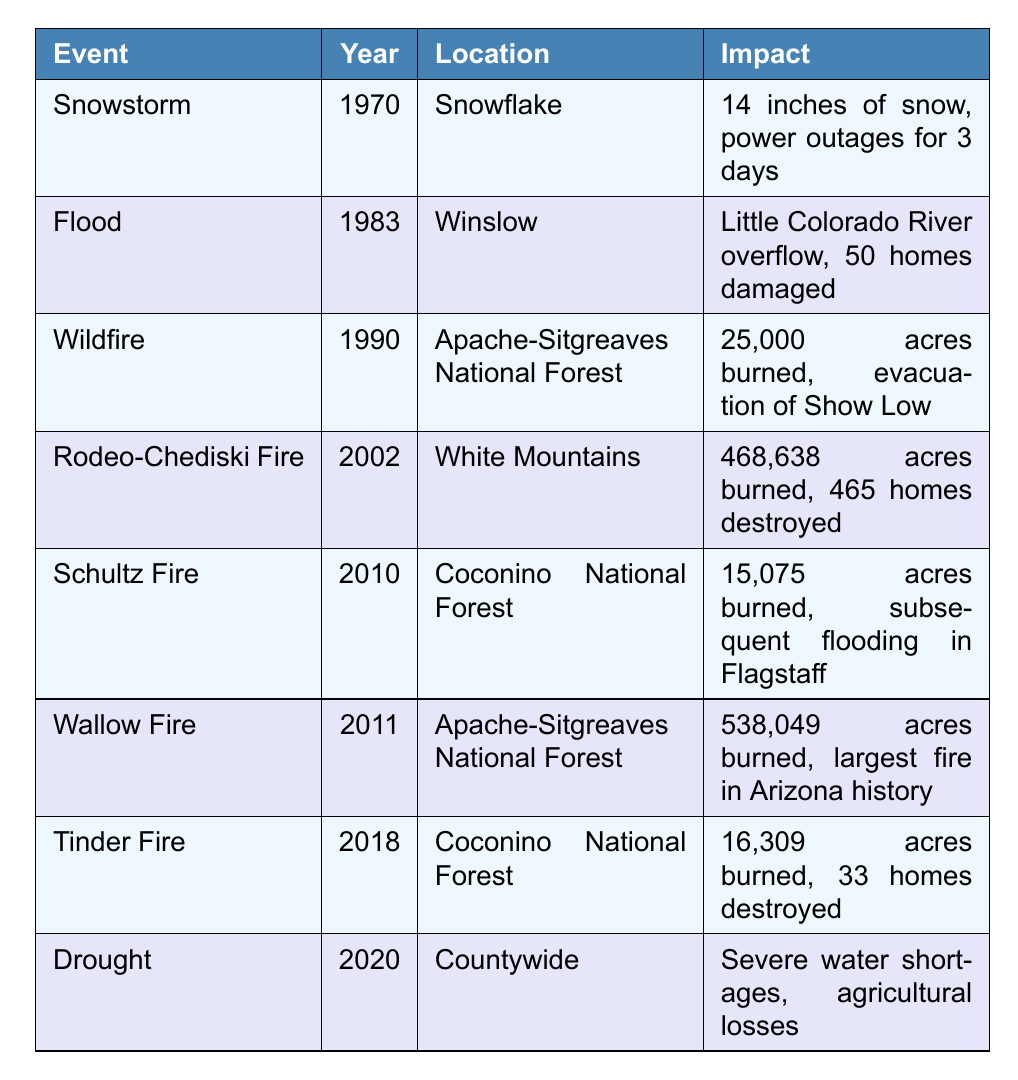What year did the Rodeo-Chediski Fire occur? The table lists the yearly disasters, and the Rodeo-Chediski Fire is specifically noted under the year 2002.
Answer: 2002 How many homes were destroyed in the Wallow Fire? The table states that the Wallow Fire destroyed 465 homes.
Answer: 465 homes Which disaster had the largest area burned, and what was that area? Comparing the impact of disasters listed, the Wallow Fire has the largest area burned at 538,049 acres according to the table.
Answer: Wallow Fire, 538,049 acres Was there a natural disaster in Navajo County that resulted in power outages? In the table, the 1970 Snowstorm resulted in power outages for 3 days.
Answer: Yes Which events occurred in the Apache-Sitgreaves National Forest? The table lists two events in the Apache-Sitgreaves National Forest: the Wildfire in 1990 and the Wallow Fire in 2011.
Answer: Wildfire (1990), Wallow Fire (2011) What was the total area burned by all wildfires mentioned in the table? To find the total area burned, sum the burned areas of Rodeo-Chediski Fire (468,638 acres), Schultz Fire (15,075 acres), Wallow Fire (538,049 acres), and Tinder Fire (16,309 acres). Total: 468,638 + 15,075 + 538,049 + 16,309 = 1,038,071 acres.
Answer: 1,038,071 acres How many years passed between the first recorded disaster and the Wallow Fire? The first disaster listed is in 1970, and the Wallow Fire is in 2011. Subtracting these years gives 2011 - 1970 = 41 years.
Answer: 41 years What was a common consequence of the wildfire events listed in the table? Both the Rodeo-Chediski Fire in 2002 and the Wallow Fire in 2011 resulted in extensive damage and destruction of homes, with 465 homes destroyed in Rodeo-Chediski Fire. This indicates that wildfires had significant impacts on residential areas.
Answer: Extensive home destruction How does the impact of the 2020 drought compare to the flood in 1983? The 2020 drought resulted in severe water shortages and agricultural losses, while the 1983 flood caused damage to 50 homes. The drought had a broader impact on water resources and agriculture, whereas the flood impacted housing specifically.
Answer: Drought had broader impacts Which disaster was noted for its significant snowfall? The Snowstorm in 1970 is noted for 14 inches of snow.
Answer: Snowstorm (1970) 